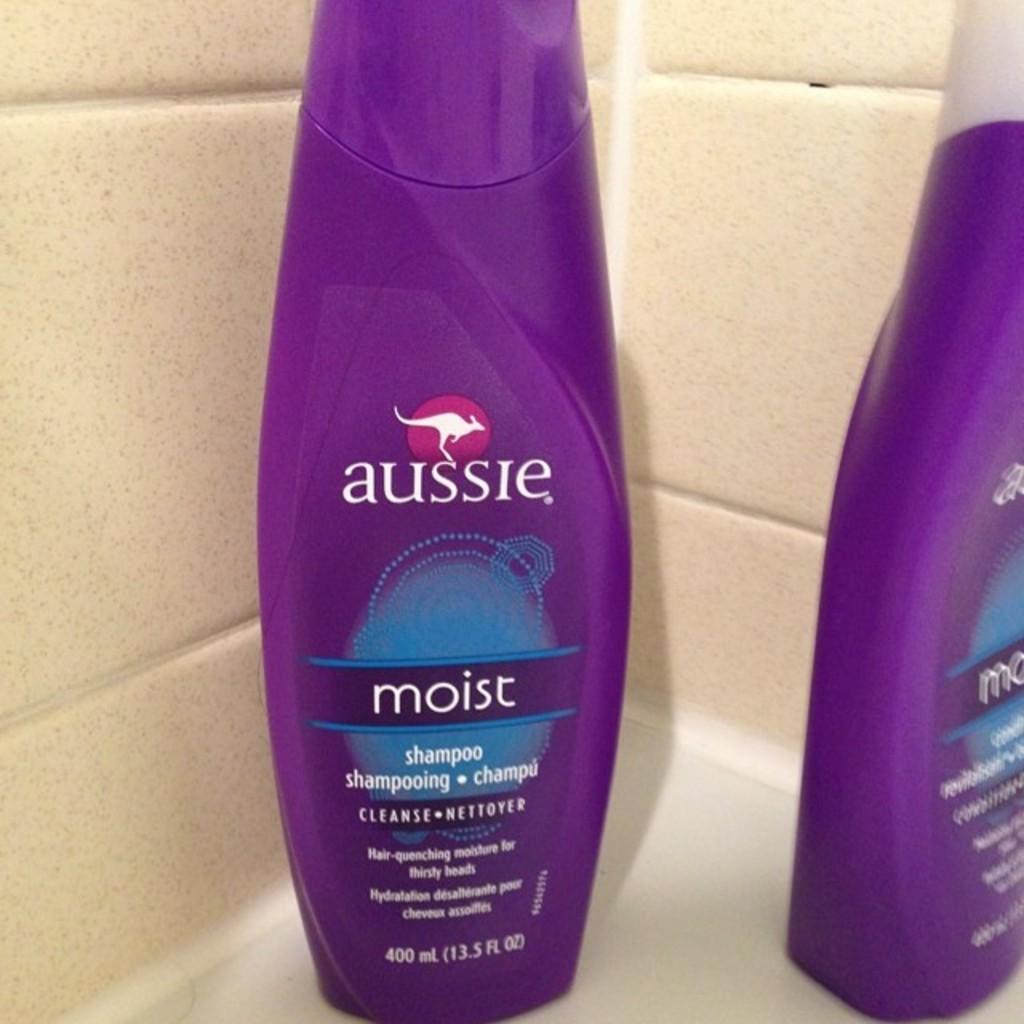Could you give a brief overview of what you see in this image? In the image there are two bottles and the first bottle is a shampoo bottle. Behind the bottles there are tiles. 